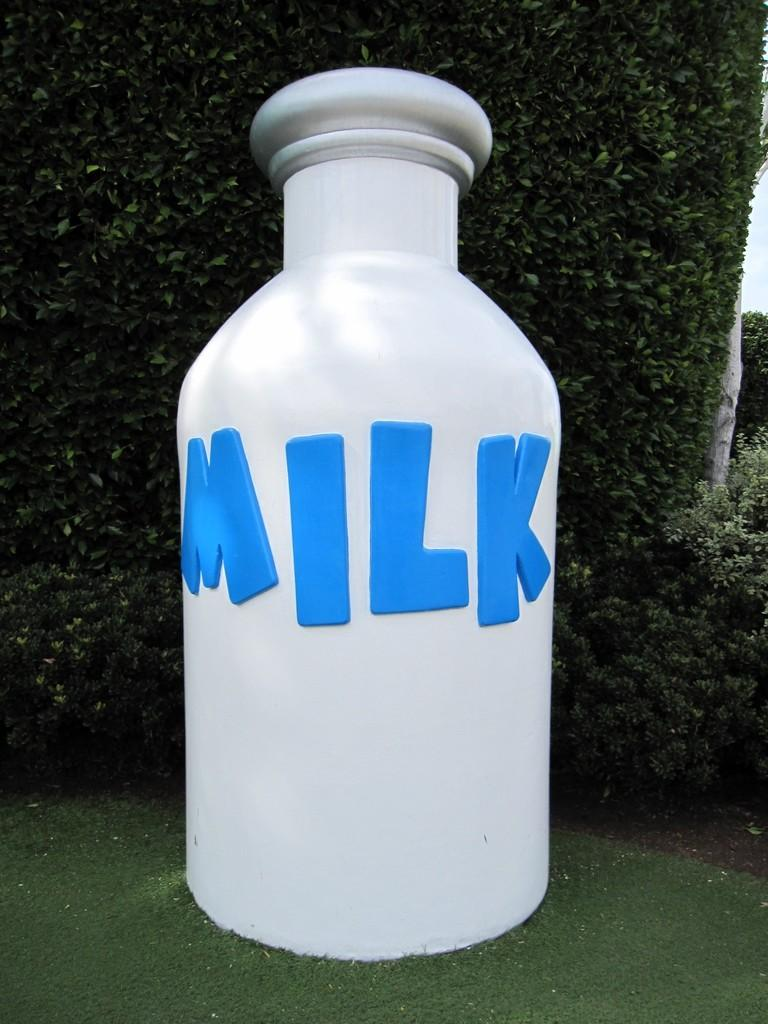<image>
Create a compact narrative representing the image presented. A large image of a white milk bottle with blue lettering. 